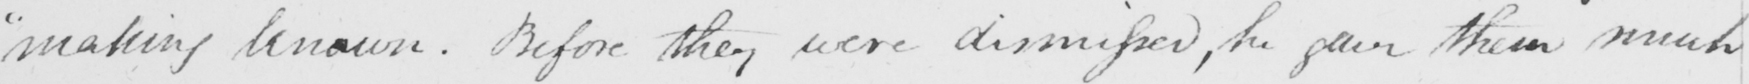Can you read and transcribe this handwriting? " making known . Before they were dismissed , he gave them much 